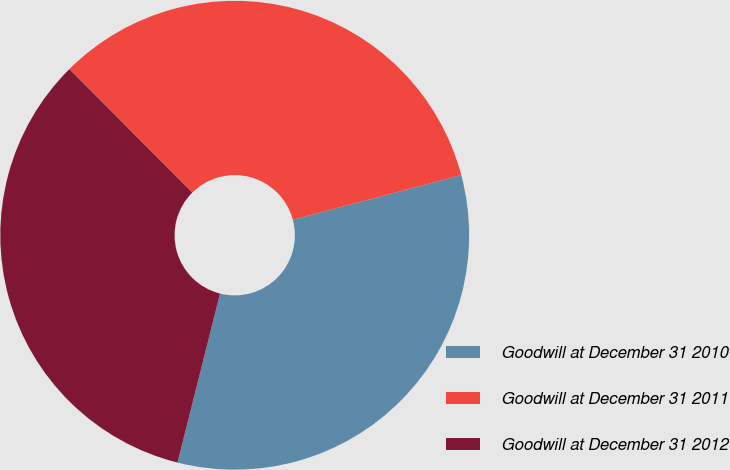Convert chart. <chart><loc_0><loc_0><loc_500><loc_500><pie_chart><fcel>Goodwill at December 31 2010<fcel>Goodwill at December 31 2011<fcel>Goodwill at December 31 2012<nl><fcel>33.06%<fcel>33.33%<fcel>33.61%<nl></chart> 